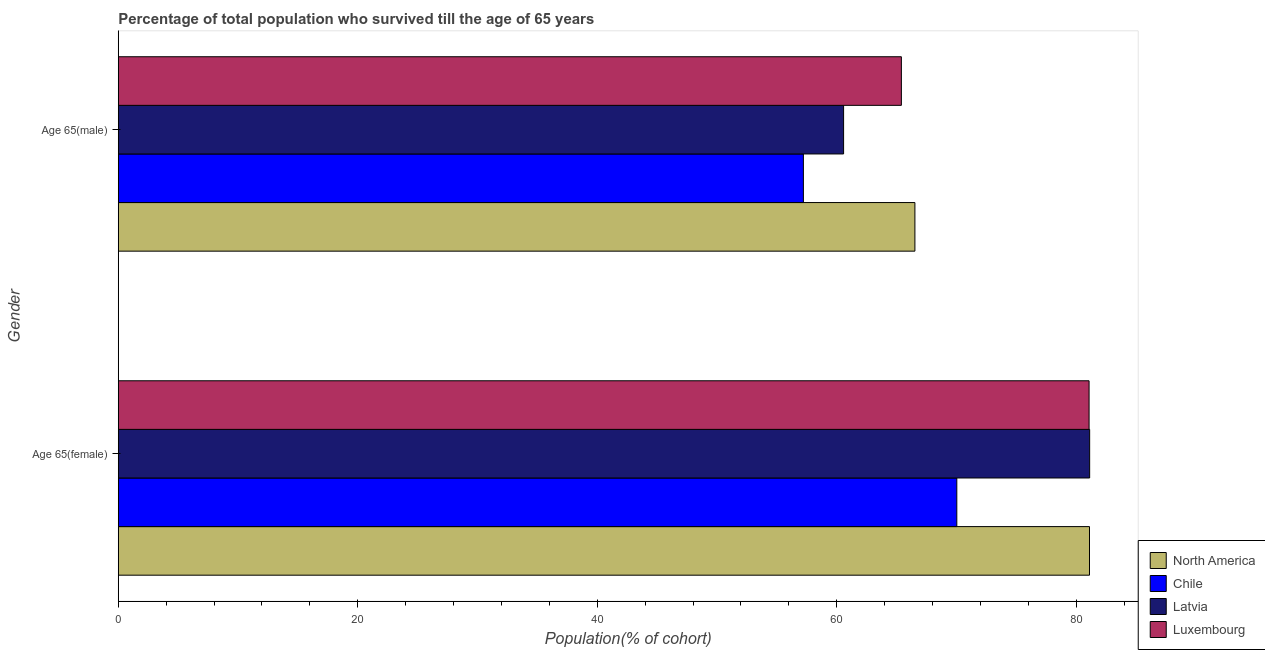How many different coloured bars are there?
Ensure brevity in your answer.  4. How many groups of bars are there?
Provide a succinct answer. 2. Are the number of bars on each tick of the Y-axis equal?
Offer a very short reply. Yes. How many bars are there on the 1st tick from the top?
Your answer should be very brief. 4. What is the label of the 1st group of bars from the top?
Keep it short and to the point. Age 65(male). What is the percentage of female population who survived till age of 65 in Luxembourg?
Give a very brief answer. 81.07. Across all countries, what is the maximum percentage of female population who survived till age of 65?
Your response must be concise. 81.12. Across all countries, what is the minimum percentage of female population who survived till age of 65?
Provide a short and direct response. 70.02. In which country was the percentage of male population who survived till age of 65 maximum?
Provide a short and direct response. North America. What is the total percentage of male population who survived till age of 65 in the graph?
Ensure brevity in your answer.  249.7. What is the difference between the percentage of male population who survived till age of 65 in Luxembourg and that in North America?
Provide a succinct answer. -1.13. What is the difference between the percentage of female population who survived till age of 65 in Luxembourg and the percentage of male population who survived till age of 65 in North America?
Provide a succinct answer. 14.55. What is the average percentage of male population who survived till age of 65 per country?
Your response must be concise. 62.42. What is the difference between the percentage of male population who survived till age of 65 and percentage of female population who survived till age of 65 in North America?
Provide a succinct answer. -14.58. What is the ratio of the percentage of female population who survived till age of 65 in Chile to that in North America?
Your response must be concise. 0.86. Is the percentage of male population who survived till age of 65 in Luxembourg less than that in Chile?
Give a very brief answer. No. In how many countries, is the percentage of male population who survived till age of 65 greater than the average percentage of male population who survived till age of 65 taken over all countries?
Make the answer very short. 2. What does the 1st bar from the top in Age 65(male) represents?
Offer a terse response. Luxembourg. What does the 3rd bar from the bottom in Age 65(female) represents?
Keep it short and to the point. Latvia. Are all the bars in the graph horizontal?
Make the answer very short. Yes. What is the difference between two consecutive major ticks on the X-axis?
Keep it short and to the point. 20. How many legend labels are there?
Provide a succinct answer. 4. How are the legend labels stacked?
Your response must be concise. Vertical. What is the title of the graph?
Your answer should be compact. Percentage of total population who survived till the age of 65 years. Does "Gambia, The" appear as one of the legend labels in the graph?
Offer a very short reply. No. What is the label or title of the X-axis?
Make the answer very short. Population(% of cohort). What is the Population(% of cohort) of North America in Age 65(female)?
Your response must be concise. 81.1. What is the Population(% of cohort) in Chile in Age 65(female)?
Keep it short and to the point. 70.02. What is the Population(% of cohort) in Latvia in Age 65(female)?
Keep it short and to the point. 81.12. What is the Population(% of cohort) of Luxembourg in Age 65(female)?
Give a very brief answer. 81.07. What is the Population(% of cohort) in North America in Age 65(male)?
Provide a succinct answer. 66.52. What is the Population(% of cohort) of Chile in Age 65(male)?
Make the answer very short. 57.21. What is the Population(% of cohort) of Latvia in Age 65(male)?
Offer a very short reply. 60.57. What is the Population(% of cohort) of Luxembourg in Age 65(male)?
Offer a terse response. 65.39. Across all Gender, what is the maximum Population(% of cohort) of North America?
Ensure brevity in your answer.  81.1. Across all Gender, what is the maximum Population(% of cohort) of Chile?
Your response must be concise. 70.02. Across all Gender, what is the maximum Population(% of cohort) of Latvia?
Offer a very short reply. 81.12. Across all Gender, what is the maximum Population(% of cohort) of Luxembourg?
Make the answer very short. 81.07. Across all Gender, what is the minimum Population(% of cohort) in North America?
Ensure brevity in your answer.  66.52. Across all Gender, what is the minimum Population(% of cohort) of Chile?
Keep it short and to the point. 57.21. Across all Gender, what is the minimum Population(% of cohort) of Latvia?
Your answer should be very brief. 60.57. Across all Gender, what is the minimum Population(% of cohort) in Luxembourg?
Offer a very short reply. 65.39. What is the total Population(% of cohort) of North America in the graph?
Ensure brevity in your answer.  147.63. What is the total Population(% of cohort) in Chile in the graph?
Keep it short and to the point. 127.24. What is the total Population(% of cohort) of Latvia in the graph?
Provide a short and direct response. 141.69. What is the total Population(% of cohort) of Luxembourg in the graph?
Offer a terse response. 146.46. What is the difference between the Population(% of cohort) of North America in Age 65(female) and that in Age 65(male)?
Offer a very short reply. 14.58. What is the difference between the Population(% of cohort) in Chile in Age 65(female) and that in Age 65(male)?
Offer a very short reply. 12.81. What is the difference between the Population(% of cohort) of Latvia in Age 65(female) and that in Age 65(male)?
Offer a terse response. 20.55. What is the difference between the Population(% of cohort) in Luxembourg in Age 65(female) and that in Age 65(male)?
Offer a terse response. 15.67. What is the difference between the Population(% of cohort) of North America in Age 65(female) and the Population(% of cohort) of Chile in Age 65(male)?
Give a very brief answer. 23.89. What is the difference between the Population(% of cohort) of North America in Age 65(female) and the Population(% of cohort) of Latvia in Age 65(male)?
Give a very brief answer. 20.54. What is the difference between the Population(% of cohort) of North America in Age 65(female) and the Population(% of cohort) of Luxembourg in Age 65(male)?
Ensure brevity in your answer.  15.71. What is the difference between the Population(% of cohort) in Chile in Age 65(female) and the Population(% of cohort) in Latvia in Age 65(male)?
Provide a succinct answer. 9.46. What is the difference between the Population(% of cohort) in Chile in Age 65(female) and the Population(% of cohort) in Luxembourg in Age 65(male)?
Offer a very short reply. 4.63. What is the difference between the Population(% of cohort) of Latvia in Age 65(female) and the Population(% of cohort) of Luxembourg in Age 65(male)?
Keep it short and to the point. 15.72. What is the average Population(% of cohort) of North America per Gender?
Make the answer very short. 73.81. What is the average Population(% of cohort) in Chile per Gender?
Provide a succinct answer. 63.62. What is the average Population(% of cohort) of Latvia per Gender?
Provide a short and direct response. 70.84. What is the average Population(% of cohort) in Luxembourg per Gender?
Provide a succinct answer. 73.23. What is the difference between the Population(% of cohort) in North America and Population(% of cohort) in Chile in Age 65(female)?
Provide a short and direct response. 11.08. What is the difference between the Population(% of cohort) in North America and Population(% of cohort) in Latvia in Age 65(female)?
Your answer should be very brief. -0.01. What is the difference between the Population(% of cohort) of North America and Population(% of cohort) of Luxembourg in Age 65(female)?
Provide a short and direct response. 0.04. What is the difference between the Population(% of cohort) of Chile and Population(% of cohort) of Latvia in Age 65(female)?
Keep it short and to the point. -11.09. What is the difference between the Population(% of cohort) in Chile and Population(% of cohort) in Luxembourg in Age 65(female)?
Keep it short and to the point. -11.04. What is the difference between the Population(% of cohort) in Latvia and Population(% of cohort) in Luxembourg in Age 65(female)?
Your response must be concise. 0.05. What is the difference between the Population(% of cohort) of North America and Population(% of cohort) of Chile in Age 65(male)?
Keep it short and to the point. 9.31. What is the difference between the Population(% of cohort) in North America and Population(% of cohort) in Latvia in Age 65(male)?
Make the answer very short. 5.95. What is the difference between the Population(% of cohort) in North America and Population(% of cohort) in Luxembourg in Age 65(male)?
Provide a succinct answer. 1.13. What is the difference between the Population(% of cohort) in Chile and Population(% of cohort) in Latvia in Age 65(male)?
Your answer should be very brief. -3.36. What is the difference between the Population(% of cohort) in Chile and Population(% of cohort) in Luxembourg in Age 65(male)?
Your response must be concise. -8.18. What is the difference between the Population(% of cohort) in Latvia and Population(% of cohort) in Luxembourg in Age 65(male)?
Give a very brief answer. -4.83. What is the ratio of the Population(% of cohort) of North America in Age 65(female) to that in Age 65(male)?
Your answer should be compact. 1.22. What is the ratio of the Population(% of cohort) of Chile in Age 65(female) to that in Age 65(male)?
Your response must be concise. 1.22. What is the ratio of the Population(% of cohort) in Latvia in Age 65(female) to that in Age 65(male)?
Provide a succinct answer. 1.34. What is the ratio of the Population(% of cohort) of Luxembourg in Age 65(female) to that in Age 65(male)?
Offer a very short reply. 1.24. What is the difference between the highest and the second highest Population(% of cohort) in North America?
Provide a succinct answer. 14.58. What is the difference between the highest and the second highest Population(% of cohort) of Chile?
Provide a succinct answer. 12.81. What is the difference between the highest and the second highest Population(% of cohort) of Latvia?
Your answer should be compact. 20.55. What is the difference between the highest and the second highest Population(% of cohort) in Luxembourg?
Provide a succinct answer. 15.67. What is the difference between the highest and the lowest Population(% of cohort) of North America?
Give a very brief answer. 14.58. What is the difference between the highest and the lowest Population(% of cohort) in Chile?
Make the answer very short. 12.81. What is the difference between the highest and the lowest Population(% of cohort) of Latvia?
Offer a terse response. 20.55. What is the difference between the highest and the lowest Population(% of cohort) of Luxembourg?
Provide a succinct answer. 15.67. 